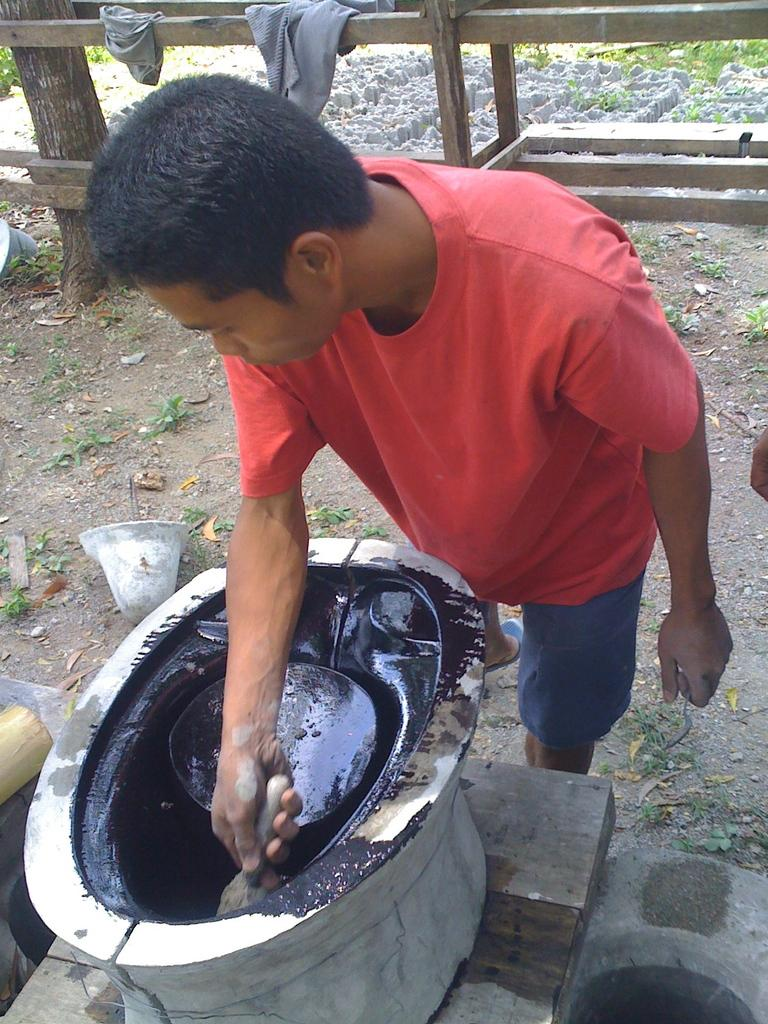What is the man in the image doing? The man is painting. What type of clothing is the man wearing on his upper body? The man is wearing a t-shirt. What type of clothing is the man wearing on his lower body? The man is wearing shorts. How many fish is the man serving in the image? There are no fish or serving activity present in the image; the man is painting. 